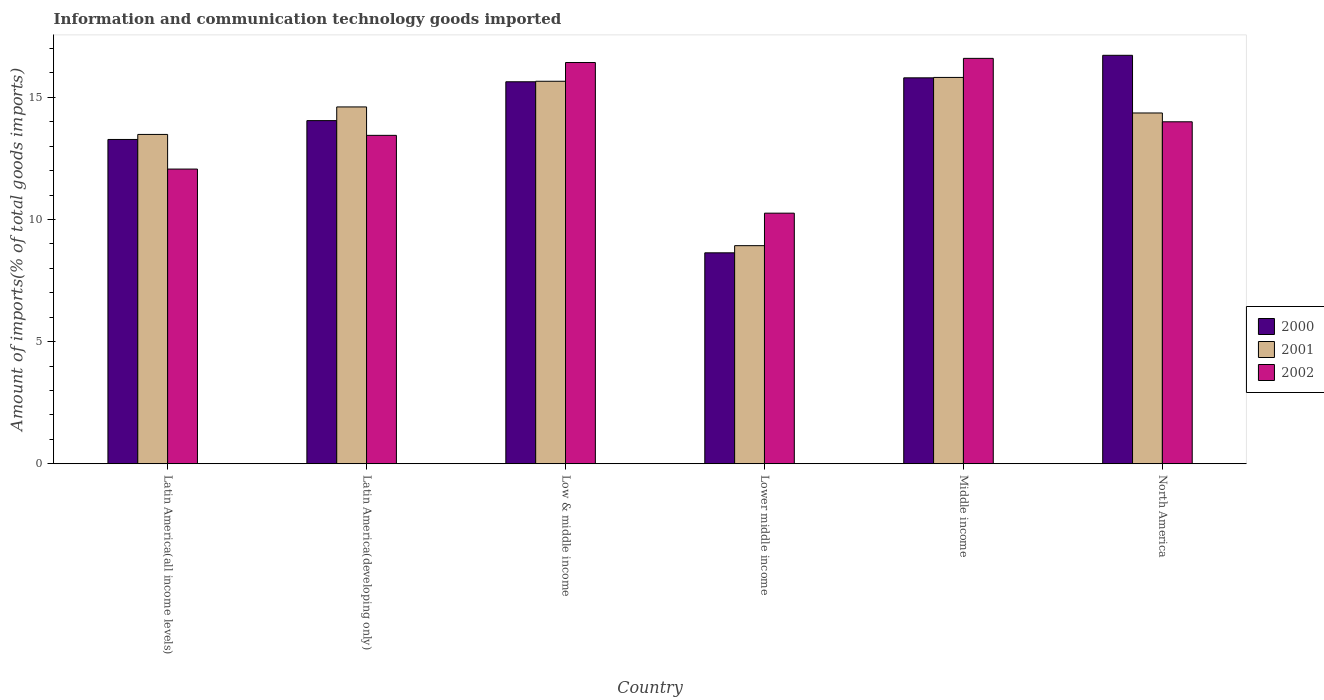How many different coloured bars are there?
Keep it short and to the point. 3. How many groups of bars are there?
Provide a short and direct response. 6. Are the number of bars per tick equal to the number of legend labels?
Make the answer very short. Yes. How many bars are there on the 4th tick from the right?
Make the answer very short. 3. What is the amount of goods imported in 2001 in Latin America(developing only)?
Your response must be concise. 14.61. Across all countries, what is the maximum amount of goods imported in 2001?
Keep it short and to the point. 15.81. Across all countries, what is the minimum amount of goods imported in 2001?
Provide a short and direct response. 8.93. In which country was the amount of goods imported in 2002 minimum?
Provide a short and direct response. Lower middle income. What is the total amount of goods imported in 2002 in the graph?
Provide a succinct answer. 82.78. What is the difference between the amount of goods imported in 2000 in Latin America(developing only) and that in Middle income?
Your answer should be very brief. -1.75. What is the difference between the amount of goods imported in 2001 in Lower middle income and the amount of goods imported in 2002 in North America?
Your response must be concise. -5.07. What is the average amount of goods imported in 2000 per country?
Provide a short and direct response. 14.02. What is the difference between the amount of goods imported of/in 2001 and amount of goods imported of/in 2002 in Latin America(all income levels)?
Your answer should be very brief. 1.42. In how many countries, is the amount of goods imported in 2002 greater than 11 %?
Offer a terse response. 5. What is the ratio of the amount of goods imported in 2002 in Latin America(developing only) to that in Lower middle income?
Offer a terse response. 1.31. What is the difference between the highest and the second highest amount of goods imported in 2002?
Provide a succinct answer. 0.17. What is the difference between the highest and the lowest amount of goods imported in 2000?
Your answer should be very brief. 8.09. What does the 1st bar from the left in North America represents?
Give a very brief answer. 2000. What does the 1st bar from the right in Latin America(all income levels) represents?
Provide a succinct answer. 2002. How many bars are there?
Ensure brevity in your answer.  18. Are all the bars in the graph horizontal?
Ensure brevity in your answer.  No. What is the difference between two consecutive major ticks on the Y-axis?
Provide a short and direct response. 5. Are the values on the major ticks of Y-axis written in scientific E-notation?
Offer a very short reply. No. Does the graph contain any zero values?
Your response must be concise. No. Where does the legend appear in the graph?
Give a very brief answer. Center right. What is the title of the graph?
Make the answer very short. Information and communication technology goods imported. Does "1974" appear as one of the legend labels in the graph?
Offer a very short reply. No. What is the label or title of the Y-axis?
Provide a succinct answer. Amount of imports(% of total goods imports). What is the Amount of imports(% of total goods imports) of 2000 in Latin America(all income levels)?
Ensure brevity in your answer.  13.27. What is the Amount of imports(% of total goods imports) of 2001 in Latin America(all income levels)?
Keep it short and to the point. 13.48. What is the Amount of imports(% of total goods imports) in 2002 in Latin America(all income levels)?
Ensure brevity in your answer.  12.06. What is the Amount of imports(% of total goods imports) in 2000 in Latin America(developing only)?
Your answer should be very brief. 14.05. What is the Amount of imports(% of total goods imports) of 2001 in Latin America(developing only)?
Give a very brief answer. 14.61. What is the Amount of imports(% of total goods imports) of 2002 in Latin America(developing only)?
Ensure brevity in your answer.  13.44. What is the Amount of imports(% of total goods imports) of 2000 in Low & middle income?
Provide a succinct answer. 15.64. What is the Amount of imports(% of total goods imports) in 2001 in Low & middle income?
Your response must be concise. 15.66. What is the Amount of imports(% of total goods imports) of 2002 in Low & middle income?
Ensure brevity in your answer.  16.42. What is the Amount of imports(% of total goods imports) in 2000 in Lower middle income?
Your response must be concise. 8.63. What is the Amount of imports(% of total goods imports) of 2001 in Lower middle income?
Your response must be concise. 8.93. What is the Amount of imports(% of total goods imports) in 2002 in Lower middle income?
Offer a very short reply. 10.26. What is the Amount of imports(% of total goods imports) in 2000 in Middle income?
Your response must be concise. 15.8. What is the Amount of imports(% of total goods imports) of 2001 in Middle income?
Provide a short and direct response. 15.81. What is the Amount of imports(% of total goods imports) in 2002 in Middle income?
Offer a terse response. 16.59. What is the Amount of imports(% of total goods imports) in 2000 in North America?
Your answer should be very brief. 16.72. What is the Amount of imports(% of total goods imports) of 2001 in North America?
Your answer should be compact. 14.36. What is the Amount of imports(% of total goods imports) of 2002 in North America?
Ensure brevity in your answer.  14. Across all countries, what is the maximum Amount of imports(% of total goods imports) of 2000?
Your response must be concise. 16.72. Across all countries, what is the maximum Amount of imports(% of total goods imports) in 2001?
Your response must be concise. 15.81. Across all countries, what is the maximum Amount of imports(% of total goods imports) in 2002?
Your answer should be very brief. 16.59. Across all countries, what is the minimum Amount of imports(% of total goods imports) of 2000?
Your response must be concise. 8.63. Across all countries, what is the minimum Amount of imports(% of total goods imports) in 2001?
Offer a very short reply. 8.93. Across all countries, what is the minimum Amount of imports(% of total goods imports) in 2002?
Your response must be concise. 10.26. What is the total Amount of imports(% of total goods imports) in 2000 in the graph?
Your answer should be very brief. 84.11. What is the total Amount of imports(% of total goods imports) of 2001 in the graph?
Offer a very short reply. 82.85. What is the total Amount of imports(% of total goods imports) in 2002 in the graph?
Provide a short and direct response. 82.78. What is the difference between the Amount of imports(% of total goods imports) of 2000 in Latin America(all income levels) and that in Latin America(developing only)?
Give a very brief answer. -0.77. What is the difference between the Amount of imports(% of total goods imports) in 2001 in Latin America(all income levels) and that in Latin America(developing only)?
Make the answer very short. -1.13. What is the difference between the Amount of imports(% of total goods imports) in 2002 in Latin America(all income levels) and that in Latin America(developing only)?
Ensure brevity in your answer.  -1.38. What is the difference between the Amount of imports(% of total goods imports) in 2000 in Latin America(all income levels) and that in Low & middle income?
Your response must be concise. -2.36. What is the difference between the Amount of imports(% of total goods imports) of 2001 in Latin America(all income levels) and that in Low & middle income?
Your answer should be compact. -2.18. What is the difference between the Amount of imports(% of total goods imports) in 2002 in Latin America(all income levels) and that in Low & middle income?
Ensure brevity in your answer.  -4.36. What is the difference between the Amount of imports(% of total goods imports) of 2000 in Latin America(all income levels) and that in Lower middle income?
Make the answer very short. 4.64. What is the difference between the Amount of imports(% of total goods imports) of 2001 in Latin America(all income levels) and that in Lower middle income?
Your response must be concise. 4.55. What is the difference between the Amount of imports(% of total goods imports) in 2002 in Latin America(all income levels) and that in Lower middle income?
Make the answer very short. 1.8. What is the difference between the Amount of imports(% of total goods imports) in 2000 in Latin America(all income levels) and that in Middle income?
Provide a short and direct response. -2.52. What is the difference between the Amount of imports(% of total goods imports) in 2001 in Latin America(all income levels) and that in Middle income?
Your answer should be compact. -2.33. What is the difference between the Amount of imports(% of total goods imports) in 2002 in Latin America(all income levels) and that in Middle income?
Offer a terse response. -4.53. What is the difference between the Amount of imports(% of total goods imports) in 2000 in Latin America(all income levels) and that in North America?
Offer a terse response. -3.45. What is the difference between the Amount of imports(% of total goods imports) in 2001 in Latin America(all income levels) and that in North America?
Your response must be concise. -0.88. What is the difference between the Amount of imports(% of total goods imports) of 2002 in Latin America(all income levels) and that in North America?
Provide a short and direct response. -1.94. What is the difference between the Amount of imports(% of total goods imports) in 2000 in Latin America(developing only) and that in Low & middle income?
Keep it short and to the point. -1.59. What is the difference between the Amount of imports(% of total goods imports) of 2001 in Latin America(developing only) and that in Low & middle income?
Give a very brief answer. -1.05. What is the difference between the Amount of imports(% of total goods imports) of 2002 in Latin America(developing only) and that in Low & middle income?
Offer a terse response. -2.98. What is the difference between the Amount of imports(% of total goods imports) in 2000 in Latin America(developing only) and that in Lower middle income?
Provide a short and direct response. 5.41. What is the difference between the Amount of imports(% of total goods imports) of 2001 in Latin America(developing only) and that in Lower middle income?
Offer a very short reply. 5.68. What is the difference between the Amount of imports(% of total goods imports) of 2002 in Latin America(developing only) and that in Lower middle income?
Your response must be concise. 3.19. What is the difference between the Amount of imports(% of total goods imports) in 2000 in Latin America(developing only) and that in Middle income?
Your answer should be very brief. -1.75. What is the difference between the Amount of imports(% of total goods imports) of 2001 in Latin America(developing only) and that in Middle income?
Give a very brief answer. -1.21. What is the difference between the Amount of imports(% of total goods imports) in 2002 in Latin America(developing only) and that in Middle income?
Keep it short and to the point. -3.15. What is the difference between the Amount of imports(% of total goods imports) of 2000 in Latin America(developing only) and that in North America?
Your response must be concise. -2.67. What is the difference between the Amount of imports(% of total goods imports) of 2001 in Latin America(developing only) and that in North America?
Offer a terse response. 0.25. What is the difference between the Amount of imports(% of total goods imports) of 2002 in Latin America(developing only) and that in North America?
Provide a succinct answer. -0.56. What is the difference between the Amount of imports(% of total goods imports) of 2000 in Low & middle income and that in Lower middle income?
Provide a short and direct response. 7. What is the difference between the Amount of imports(% of total goods imports) of 2001 in Low & middle income and that in Lower middle income?
Your answer should be very brief. 6.73. What is the difference between the Amount of imports(% of total goods imports) in 2002 in Low & middle income and that in Lower middle income?
Make the answer very short. 6.17. What is the difference between the Amount of imports(% of total goods imports) in 2000 in Low & middle income and that in Middle income?
Your answer should be very brief. -0.16. What is the difference between the Amount of imports(% of total goods imports) of 2001 in Low & middle income and that in Middle income?
Keep it short and to the point. -0.16. What is the difference between the Amount of imports(% of total goods imports) of 2002 in Low & middle income and that in Middle income?
Give a very brief answer. -0.17. What is the difference between the Amount of imports(% of total goods imports) of 2000 in Low & middle income and that in North America?
Your response must be concise. -1.08. What is the difference between the Amount of imports(% of total goods imports) of 2001 in Low & middle income and that in North America?
Provide a succinct answer. 1.3. What is the difference between the Amount of imports(% of total goods imports) in 2002 in Low & middle income and that in North America?
Give a very brief answer. 2.43. What is the difference between the Amount of imports(% of total goods imports) of 2000 in Lower middle income and that in Middle income?
Your answer should be compact. -7.16. What is the difference between the Amount of imports(% of total goods imports) of 2001 in Lower middle income and that in Middle income?
Offer a terse response. -6.89. What is the difference between the Amount of imports(% of total goods imports) in 2002 in Lower middle income and that in Middle income?
Make the answer very short. -6.34. What is the difference between the Amount of imports(% of total goods imports) in 2000 in Lower middle income and that in North America?
Your answer should be very brief. -8.09. What is the difference between the Amount of imports(% of total goods imports) of 2001 in Lower middle income and that in North America?
Your response must be concise. -5.43. What is the difference between the Amount of imports(% of total goods imports) in 2002 in Lower middle income and that in North America?
Provide a succinct answer. -3.74. What is the difference between the Amount of imports(% of total goods imports) in 2000 in Middle income and that in North America?
Make the answer very short. -0.92. What is the difference between the Amount of imports(% of total goods imports) of 2001 in Middle income and that in North America?
Offer a very short reply. 1.46. What is the difference between the Amount of imports(% of total goods imports) of 2002 in Middle income and that in North America?
Offer a very short reply. 2.6. What is the difference between the Amount of imports(% of total goods imports) in 2000 in Latin America(all income levels) and the Amount of imports(% of total goods imports) in 2001 in Latin America(developing only)?
Keep it short and to the point. -1.33. What is the difference between the Amount of imports(% of total goods imports) of 2000 in Latin America(all income levels) and the Amount of imports(% of total goods imports) of 2002 in Latin America(developing only)?
Your answer should be very brief. -0.17. What is the difference between the Amount of imports(% of total goods imports) in 2001 in Latin America(all income levels) and the Amount of imports(% of total goods imports) in 2002 in Latin America(developing only)?
Your answer should be compact. 0.04. What is the difference between the Amount of imports(% of total goods imports) of 2000 in Latin America(all income levels) and the Amount of imports(% of total goods imports) of 2001 in Low & middle income?
Ensure brevity in your answer.  -2.38. What is the difference between the Amount of imports(% of total goods imports) in 2000 in Latin America(all income levels) and the Amount of imports(% of total goods imports) in 2002 in Low & middle income?
Offer a very short reply. -3.15. What is the difference between the Amount of imports(% of total goods imports) in 2001 in Latin America(all income levels) and the Amount of imports(% of total goods imports) in 2002 in Low & middle income?
Your response must be concise. -2.94. What is the difference between the Amount of imports(% of total goods imports) in 2000 in Latin America(all income levels) and the Amount of imports(% of total goods imports) in 2001 in Lower middle income?
Offer a very short reply. 4.35. What is the difference between the Amount of imports(% of total goods imports) of 2000 in Latin America(all income levels) and the Amount of imports(% of total goods imports) of 2002 in Lower middle income?
Provide a short and direct response. 3.02. What is the difference between the Amount of imports(% of total goods imports) of 2001 in Latin America(all income levels) and the Amount of imports(% of total goods imports) of 2002 in Lower middle income?
Provide a short and direct response. 3.22. What is the difference between the Amount of imports(% of total goods imports) in 2000 in Latin America(all income levels) and the Amount of imports(% of total goods imports) in 2001 in Middle income?
Keep it short and to the point. -2.54. What is the difference between the Amount of imports(% of total goods imports) of 2000 in Latin America(all income levels) and the Amount of imports(% of total goods imports) of 2002 in Middle income?
Offer a terse response. -3.32. What is the difference between the Amount of imports(% of total goods imports) in 2001 in Latin America(all income levels) and the Amount of imports(% of total goods imports) in 2002 in Middle income?
Offer a terse response. -3.11. What is the difference between the Amount of imports(% of total goods imports) of 2000 in Latin America(all income levels) and the Amount of imports(% of total goods imports) of 2001 in North America?
Your answer should be compact. -1.08. What is the difference between the Amount of imports(% of total goods imports) in 2000 in Latin America(all income levels) and the Amount of imports(% of total goods imports) in 2002 in North America?
Keep it short and to the point. -0.72. What is the difference between the Amount of imports(% of total goods imports) of 2001 in Latin America(all income levels) and the Amount of imports(% of total goods imports) of 2002 in North America?
Offer a very short reply. -0.52. What is the difference between the Amount of imports(% of total goods imports) in 2000 in Latin America(developing only) and the Amount of imports(% of total goods imports) in 2001 in Low & middle income?
Your response must be concise. -1.61. What is the difference between the Amount of imports(% of total goods imports) in 2000 in Latin America(developing only) and the Amount of imports(% of total goods imports) in 2002 in Low & middle income?
Provide a succinct answer. -2.38. What is the difference between the Amount of imports(% of total goods imports) of 2001 in Latin America(developing only) and the Amount of imports(% of total goods imports) of 2002 in Low & middle income?
Ensure brevity in your answer.  -1.82. What is the difference between the Amount of imports(% of total goods imports) in 2000 in Latin America(developing only) and the Amount of imports(% of total goods imports) in 2001 in Lower middle income?
Your answer should be compact. 5.12. What is the difference between the Amount of imports(% of total goods imports) in 2000 in Latin America(developing only) and the Amount of imports(% of total goods imports) in 2002 in Lower middle income?
Your response must be concise. 3.79. What is the difference between the Amount of imports(% of total goods imports) of 2001 in Latin America(developing only) and the Amount of imports(% of total goods imports) of 2002 in Lower middle income?
Offer a terse response. 4.35. What is the difference between the Amount of imports(% of total goods imports) in 2000 in Latin America(developing only) and the Amount of imports(% of total goods imports) in 2001 in Middle income?
Ensure brevity in your answer.  -1.77. What is the difference between the Amount of imports(% of total goods imports) in 2000 in Latin America(developing only) and the Amount of imports(% of total goods imports) in 2002 in Middle income?
Your answer should be compact. -2.55. What is the difference between the Amount of imports(% of total goods imports) in 2001 in Latin America(developing only) and the Amount of imports(% of total goods imports) in 2002 in Middle income?
Your answer should be very brief. -1.99. What is the difference between the Amount of imports(% of total goods imports) of 2000 in Latin America(developing only) and the Amount of imports(% of total goods imports) of 2001 in North America?
Provide a succinct answer. -0.31. What is the difference between the Amount of imports(% of total goods imports) of 2000 in Latin America(developing only) and the Amount of imports(% of total goods imports) of 2002 in North America?
Provide a succinct answer. 0.05. What is the difference between the Amount of imports(% of total goods imports) in 2001 in Latin America(developing only) and the Amount of imports(% of total goods imports) in 2002 in North America?
Your response must be concise. 0.61. What is the difference between the Amount of imports(% of total goods imports) in 2000 in Low & middle income and the Amount of imports(% of total goods imports) in 2001 in Lower middle income?
Your answer should be compact. 6.71. What is the difference between the Amount of imports(% of total goods imports) in 2000 in Low & middle income and the Amount of imports(% of total goods imports) in 2002 in Lower middle income?
Ensure brevity in your answer.  5.38. What is the difference between the Amount of imports(% of total goods imports) of 2001 in Low & middle income and the Amount of imports(% of total goods imports) of 2002 in Lower middle income?
Your answer should be very brief. 5.4. What is the difference between the Amount of imports(% of total goods imports) of 2000 in Low & middle income and the Amount of imports(% of total goods imports) of 2001 in Middle income?
Offer a very short reply. -0.18. What is the difference between the Amount of imports(% of total goods imports) in 2000 in Low & middle income and the Amount of imports(% of total goods imports) in 2002 in Middle income?
Make the answer very short. -0.96. What is the difference between the Amount of imports(% of total goods imports) in 2001 in Low & middle income and the Amount of imports(% of total goods imports) in 2002 in Middle income?
Ensure brevity in your answer.  -0.94. What is the difference between the Amount of imports(% of total goods imports) in 2000 in Low & middle income and the Amount of imports(% of total goods imports) in 2001 in North America?
Offer a terse response. 1.28. What is the difference between the Amount of imports(% of total goods imports) of 2000 in Low & middle income and the Amount of imports(% of total goods imports) of 2002 in North America?
Your response must be concise. 1.64. What is the difference between the Amount of imports(% of total goods imports) in 2001 in Low & middle income and the Amount of imports(% of total goods imports) in 2002 in North America?
Your answer should be very brief. 1.66. What is the difference between the Amount of imports(% of total goods imports) in 2000 in Lower middle income and the Amount of imports(% of total goods imports) in 2001 in Middle income?
Offer a terse response. -7.18. What is the difference between the Amount of imports(% of total goods imports) in 2000 in Lower middle income and the Amount of imports(% of total goods imports) in 2002 in Middle income?
Offer a very short reply. -7.96. What is the difference between the Amount of imports(% of total goods imports) in 2001 in Lower middle income and the Amount of imports(% of total goods imports) in 2002 in Middle income?
Keep it short and to the point. -7.67. What is the difference between the Amount of imports(% of total goods imports) of 2000 in Lower middle income and the Amount of imports(% of total goods imports) of 2001 in North America?
Keep it short and to the point. -5.72. What is the difference between the Amount of imports(% of total goods imports) of 2000 in Lower middle income and the Amount of imports(% of total goods imports) of 2002 in North America?
Offer a very short reply. -5.36. What is the difference between the Amount of imports(% of total goods imports) of 2001 in Lower middle income and the Amount of imports(% of total goods imports) of 2002 in North America?
Offer a terse response. -5.07. What is the difference between the Amount of imports(% of total goods imports) of 2000 in Middle income and the Amount of imports(% of total goods imports) of 2001 in North America?
Your answer should be compact. 1.44. What is the difference between the Amount of imports(% of total goods imports) of 2000 in Middle income and the Amount of imports(% of total goods imports) of 2002 in North America?
Your response must be concise. 1.8. What is the difference between the Amount of imports(% of total goods imports) in 2001 in Middle income and the Amount of imports(% of total goods imports) in 2002 in North America?
Give a very brief answer. 1.82. What is the average Amount of imports(% of total goods imports) in 2000 per country?
Your answer should be very brief. 14.02. What is the average Amount of imports(% of total goods imports) in 2001 per country?
Provide a short and direct response. 13.81. What is the average Amount of imports(% of total goods imports) of 2002 per country?
Give a very brief answer. 13.8. What is the difference between the Amount of imports(% of total goods imports) of 2000 and Amount of imports(% of total goods imports) of 2001 in Latin America(all income levels)?
Your answer should be compact. -0.21. What is the difference between the Amount of imports(% of total goods imports) in 2000 and Amount of imports(% of total goods imports) in 2002 in Latin America(all income levels)?
Provide a short and direct response. 1.21. What is the difference between the Amount of imports(% of total goods imports) of 2001 and Amount of imports(% of total goods imports) of 2002 in Latin America(all income levels)?
Provide a succinct answer. 1.42. What is the difference between the Amount of imports(% of total goods imports) in 2000 and Amount of imports(% of total goods imports) in 2001 in Latin America(developing only)?
Your answer should be compact. -0.56. What is the difference between the Amount of imports(% of total goods imports) of 2000 and Amount of imports(% of total goods imports) of 2002 in Latin America(developing only)?
Provide a succinct answer. 0.6. What is the difference between the Amount of imports(% of total goods imports) of 2001 and Amount of imports(% of total goods imports) of 2002 in Latin America(developing only)?
Your answer should be compact. 1.16. What is the difference between the Amount of imports(% of total goods imports) in 2000 and Amount of imports(% of total goods imports) in 2001 in Low & middle income?
Your answer should be very brief. -0.02. What is the difference between the Amount of imports(% of total goods imports) in 2000 and Amount of imports(% of total goods imports) in 2002 in Low & middle income?
Provide a succinct answer. -0.79. What is the difference between the Amount of imports(% of total goods imports) of 2001 and Amount of imports(% of total goods imports) of 2002 in Low & middle income?
Provide a short and direct response. -0.77. What is the difference between the Amount of imports(% of total goods imports) of 2000 and Amount of imports(% of total goods imports) of 2001 in Lower middle income?
Give a very brief answer. -0.29. What is the difference between the Amount of imports(% of total goods imports) in 2000 and Amount of imports(% of total goods imports) in 2002 in Lower middle income?
Your answer should be very brief. -1.62. What is the difference between the Amount of imports(% of total goods imports) in 2001 and Amount of imports(% of total goods imports) in 2002 in Lower middle income?
Provide a short and direct response. -1.33. What is the difference between the Amount of imports(% of total goods imports) of 2000 and Amount of imports(% of total goods imports) of 2001 in Middle income?
Keep it short and to the point. -0.02. What is the difference between the Amount of imports(% of total goods imports) of 2000 and Amount of imports(% of total goods imports) of 2002 in Middle income?
Provide a short and direct response. -0.8. What is the difference between the Amount of imports(% of total goods imports) of 2001 and Amount of imports(% of total goods imports) of 2002 in Middle income?
Provide a succinct answer. -0.78. What is the difference between the Amount of imports(% of total goods imports) in 2000 and Amount of imports(% of total goods imports) in 2001 in North America?
Keep it short and to the point. 2.36. What is the difference between the Amount of imports(% of total goods imports) of 2000 and Amount of imports(% of total goods imports) of 2002 in North America?
Offer a very short reply. 2.72. What is the difference between the Amount of imports(% of total goods imports) in 2001 and Amount of imports(% of total goods imports) in 2002 in North America?
Your answer should be compact. 0.36. What is the ratio of the Amount of imports(% of total goods imports) in 2000 in Latin America(all income levels) to that in Latin America(developing only)?
Provide a short and direct response. 0.95. What is the ratio of the Amount of imports(% of total goods imports) of 2001 in Latin America(all income levels) to that in Latin America(developing only)?
Your response must be concise. 0.92. What is the ratio of the Amount of imports(% of total goods imports) of 2002 in Latin America(all income levels) to that in Latin America(developing only)?
Give a very brief answer. 0.9. What is the ratio of the Amount of imports(% of total goods imports) of 2000 in Latin America(all income levels) to that in Low & middle income?
Keep it short and to the point. 0.85. What is the ratio of the Amount of imports(% of total goods imports) in 2001 in Latin America(all income levels) to that in Low & middle income?
Provide a succinct answer. 0.86. What is the ratio of the Amount of imports(% of total goods imports) of 2002 in Latin America(all income levels) to that in Low & middle income?
Keep it short and to the point. 0.73. What is the ratio of the Amount of imports(% of total goods imports) in 2000 in Latin America(all income levels) to that in Lower middle income?
Ensure brevity in your answer.  1.54. What is the ratio of the Amount of imports(% of total goods imports) in 2001 in Latin America(all income levels) to that in Lower middle income?
Your answer should be very brief. 1.51. What is the ratio of the Amount of imports(% of total goods imports) of 2002 in Latin America(all income levels) to that in Lower middle income?
Offer a terse response. 1.18. What is the ratio of the Amount of imports(% of total goods imports) in 2000 in Latin America(all income levels) to that in Middle income?
Ensure brevity in your answer.  0.84. What is the ratio of the Amount of imports(% of total goods imports) of 2001 in Latin America(all income levels) to that in Middle income?
Offer a terse response. 0.85. What is the ratio of the Amount of imports(% of total goods imports) in 2002 in Latin America(all income levels) to that in Middle income?
Provide a short and direct response. 0.73. What is the ratio of the Amount of imports(% of total goods imports) of 2000 in Latin America(all income levels) to that in North America?
Your response must be concise. 0.79. What is the ratio of the Amount of imports(% of total goods imports) in 2001 in Latin America(all income levels) to that in North America?
Your response must be concise. 0.94. What is the ratio of the Amount of imports(% of total goods imports) of 2002 in Latin America(all income levels) to that in North America?
Give a very brief answer. 0.86. What is the ratio of the Amount of imports(% of total goods imports) of 2000 in Latin America(developing only) to that in Low & middle income?
Ensure brevity in your answer.  0.9. What is the ratio of the Amount of imports(% of total goods imports) of 2001 in Latin America(developing only) to that in Low & middle income?
Your answer should be compact. 0.93. What is the ratio of the Amount of imports(% of total goods imports) of 2002 in Latin America(developing only) to that in Low & middle income?
Your response must be concise. 0.82. What is the ratio of the Amount of imports(% of total goods imports) in 2000 in Latin America(developing only) to that in Lower middle income?
Ensure brevity in your answer.  1.63. What is the ratio of the Amount of imports(% of total goods imports) in 2001 in Latin America(developing only) to that in Lower middle income?
Your answer should be very brief. 1.64. What is the ratio of the Amount of imports(% of total goods imports) in 2002 in Latin America(developing only) to that in Lower middle income?
Your response must be concise. 1.31. What is the ratio of the Amount of imports(% of total goods imports) in 2000 in Latin America(developing only) to that in Middle income?
Provide a succinct answer. 0.89. What is the ratio of the Amount of imports(% of total goods imports) of 2001 in Latin America(developing only) to that in Middle income?
Keep it short and to the point. 0.92. What is the ratio of the Amount of imports(% of total goods imports) in 2002 in Latin America(developing only) to that in Middle income?
Provide a succinct answer. 0.81. What is the ratio of the Amount of imports(% of total goods imports) of 2000 in Latin America(developing only) to that in North America?
Keep it short and to the point. 0.84. What is the ratio of the Amount of imports(% of total goods imports) of 2001 in Latin America(developing only) to that in North America?
Your answer should be compact. 1.02. What is the ratio of the Amount of imports(% of total goods imports) in 2002 in Latin America(developing only) to that in North America?
Provide a short and direct response. 0.96. What is the ratio of the Amount of imports(% of total goods imports) of 2000 in Low & middle income to that in Lower middle income?
Offer a terse response. 1.81. What is the ratio of the Amount of imports(% of total goods imports) of 2001 in Low & middle income to that in Lower middle income?
Keep it short and to the point. 1.75. What is the ratio of the Amount of imports(% of total goods imports) in 2002 in Low & middle income to that in Lower middle income?
Your response must be concise. 1.6. What is the ratio of the Amount of imports(% of total goods imports) in 2000 in Low & middle income to that in Middle income?
Your answer should be very brief. 0.99. What is the ratio of the Amount of imports(% of total goods imports) of 2002 in Low & middle income to that in Middle income?
Your response must be concise. 0.99. What is the ratio of the Amount of imports(% of total goods imports) in 2000 in Low & middle income to that in North America?
Make the answer very short. 0.94. What is the ratio of the Amount of imports(% of total goods imports) in 2001 in Low & middle income to that in North America?
Offer a terse response. 1.09. What is the ratio of the Amount of imports(% of total goods imports) in 2002 in Low & middle income to that in North America?
Give a very brief answer. 1.17. What is the ratio of the Amount of imports(% of total goods imports) of 2000 in Lower middle income to that in Middle income?
Provide a short and direct response. 0.55. What is the ratio of the Amount of imports(% of total goods imports) of 2001 in Lower middle income to that in Middle income?
Ensure brevity in your answer.  0.56. What is the ratio of the Amount of imports(% of total goods imports) of 2002 in Lower middle income to that in Middle income?
Your response must be concise. 0.62. What is the ratio of the Amount of imports(% of total goods imports) of 2000 in Lower middle income to that in North America?
Make the answer very short. 0.52. What is the ratio of the Amount of imports(% of total goods imports) of 2001 in Lower middle income to that in North America?
Ensure brevity in your answer.  0.62. What is the ratio of the Amount of imports(% of total goods imports) of 2002 in Lower middle income to that in North America?
Provide a succinct answer. 0.73. What is the ratio of the Amount of imports(% of total goods imports) of 2000 in Middle income to that in North America?
Offer a terse response. 0.94. What is the ratio of the Amount of imports(% of total goods imports) of 2001 in Middle income to that in North America?
Offer a terse response. 1.1. What is the ratio of the Amount of imports(% of total goods imports) of 2002 in Middle income to that in North America?
Keep it short and to the point. 1.19. What is the difference between the highest and the second highest Amount of imports(% of total goods imports) of 2000?
Provide a succinct answer. 0.92. What is the difference between the highest and the second highest Amount of imports(% of total goods imports) of 2001?
Your response must be concise. 0.16. What is the difference between the highest and the second highest Amount of imports(% of total goods imports) of 2002?
Offer a terse response. 0.17. What is the difference between the highest and the lowest Amount of imports(% of total goods imports) in 2000?
Provide a short and direct response. 8.09. What is the difference between the highest and the lowest Amount of imports(% of total goods imports) in 2001?
Your answer should be compact. 6.89. What is the difference between the highest and the lowest Amount of imports(% of total goods imports) of 2002?
Ensure brevity in your answer.  6.34. 